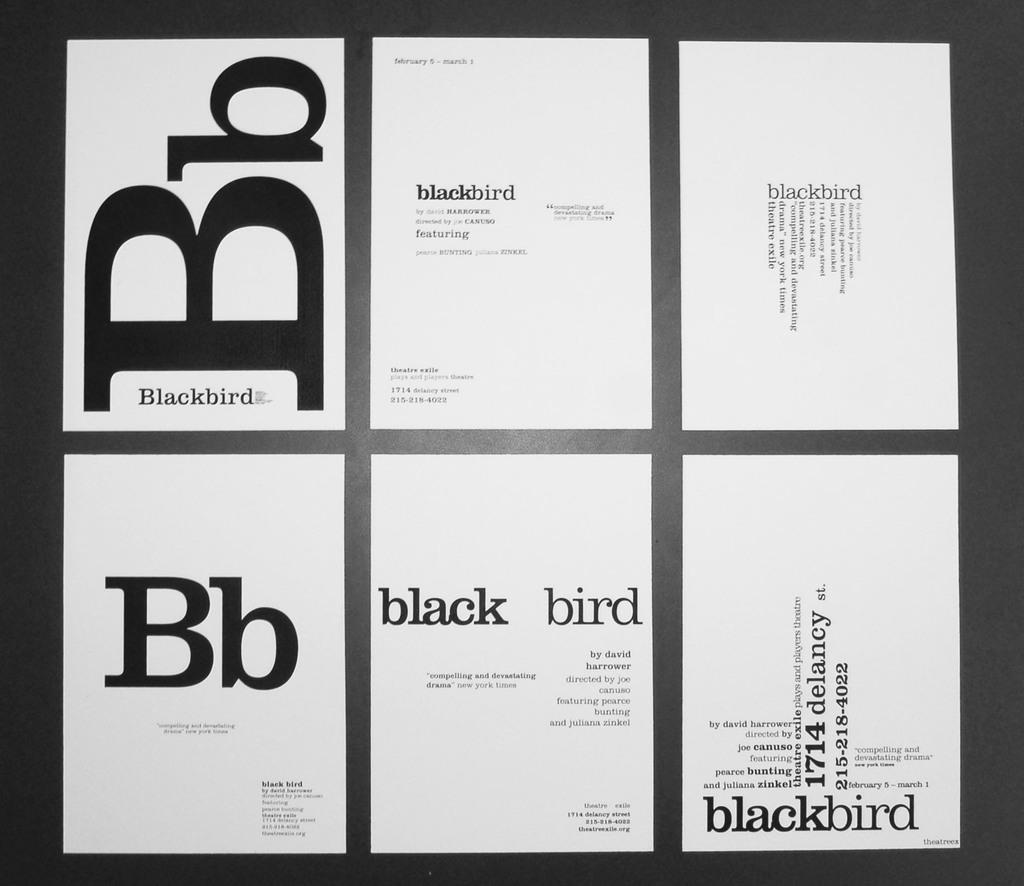<image>
Present a compact description of the photo's key features. Six pages of white paper with black text on them highlighting the word Blackbird and its abbreviation. 